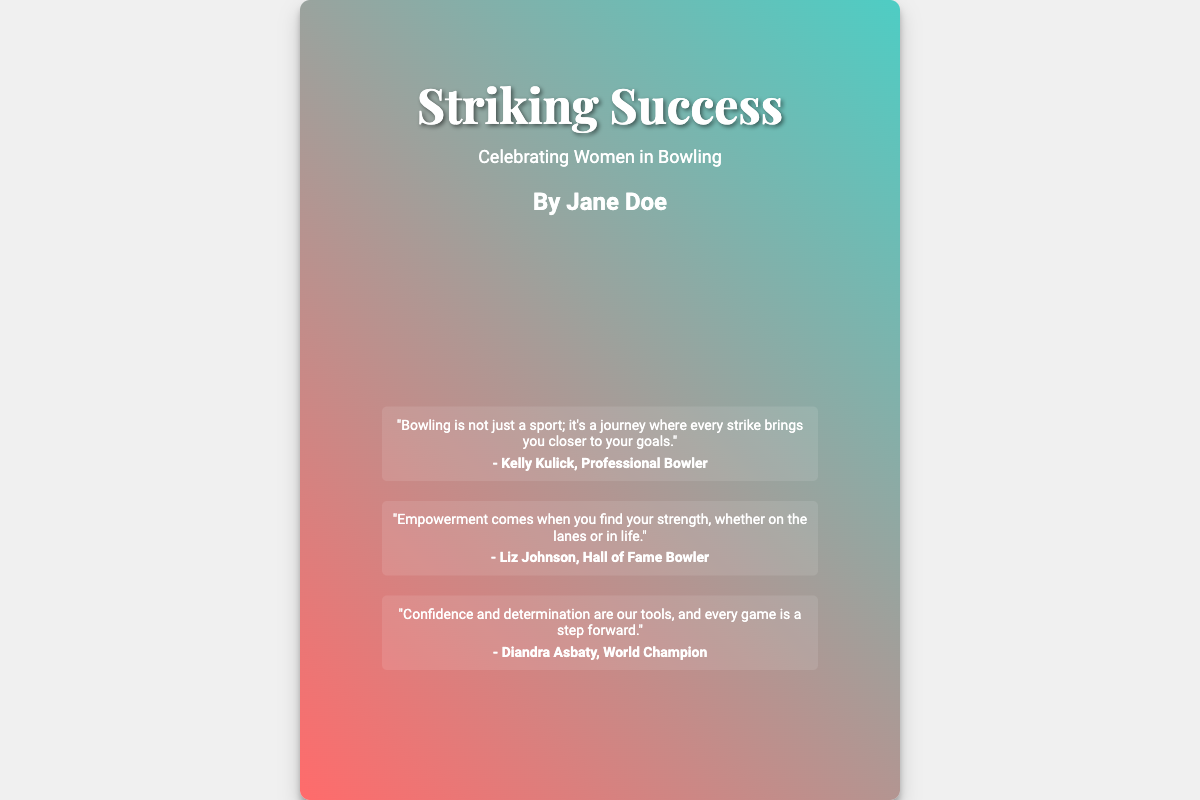What is the title of the book? The title is prominently displayed at the top of the cover.
Answer: Striking Success Who is the author of the book? The author's name is located below the subtitle on the cover.
Answer: Jane Doe What is the subtitle of the book? The subtitle provides additional context about the book's content.
Answer: Celebrating Women in Bowling How many quotes are featured on the cover? The quotes are listed in a specific section of the cover design.
Answer: Three Who is the Hall of Fame Bowler quoted in the book? The quotes include attribution to various athletes.
Answer: Liz Johnson What is the main theme highlighted in the tagline? The tagline is a concise statement about the book's focus and message.
Answer: Empowerment through the sport of bowling Which sport does the book celebrate? The cover's imagery and content indicate the specific sport.
Answer: Bowling What do the quotes from the athletes express? The quotes collectively convey a positive message related to personal growth and empowerment.
Answer: Strength and empowerment What visual elements are used in the background? The background includes a specific scene that complements the book's theme.
Answer: Bowling alley 